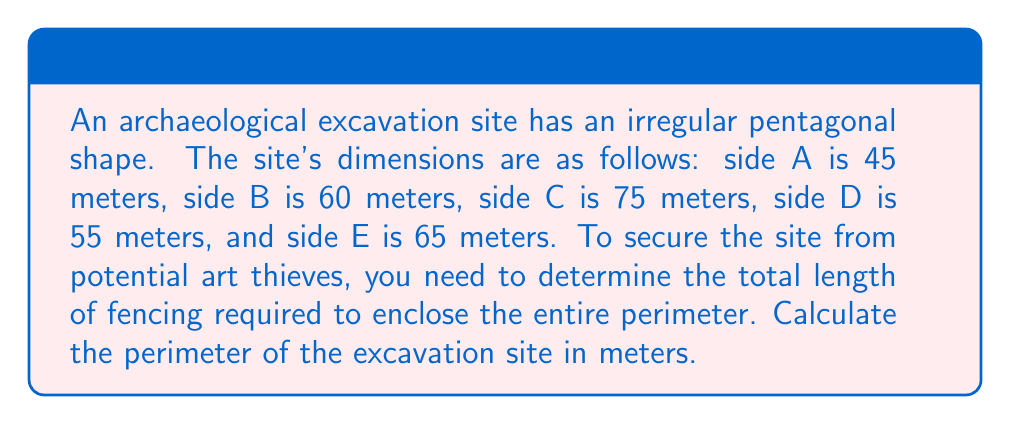Solve this math problem. To calculate the perimeter of the pentagonal excavation site, we need to sum the lengths of all five sides. Let's break it down step by step:

1. Identify the lengths of each side:
   Side A = 45 meters
   Side B = 60 meters
   Side C = 75 meters
   Side D = 55 meters
   Side E = 65 meters

2. Use the formula for the perimeter of a polygon:
   $$P = \sum_{i=1}^n s_i$$
   Where $P$ is the perimeter, and $s_i$ represents the length of each side.

3. Substitute the values into the formula:
   $$P = 45 + 60 + 75 + 55 + 65$$

4. Perform the addition:
   $$P = 300$$

Therefore, the perimeter of the excavation site is 300 meters, which is the total length of fencing required to secure the site.
Answer: 300 meters 